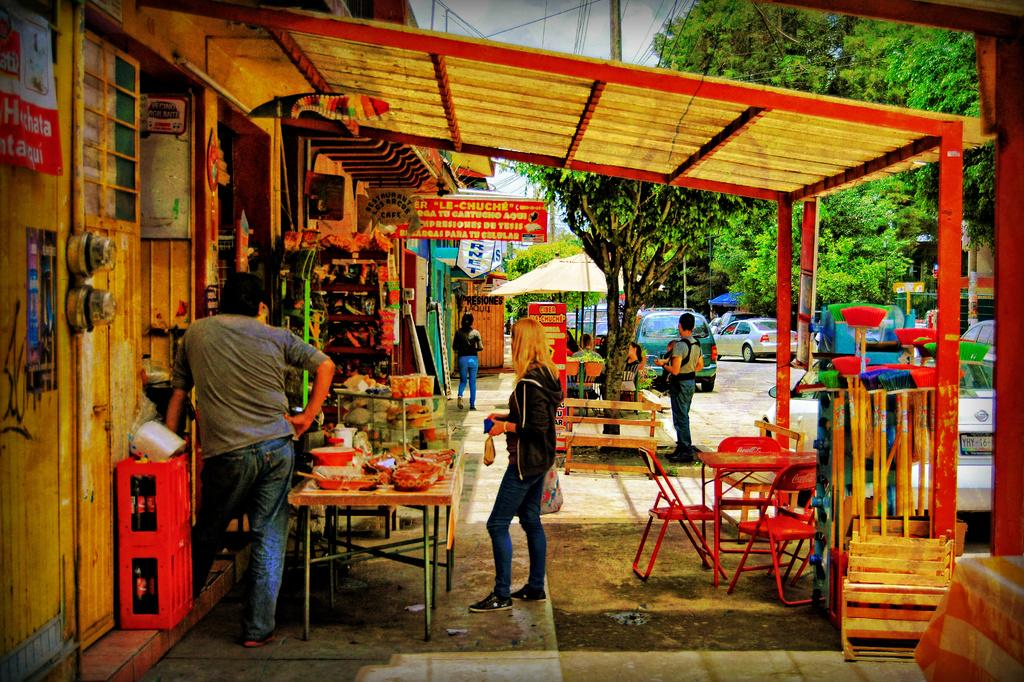Who or what can be seen in the image? There are people in the image. What type of furniture is present in the image? There are chairs and tables in the image. What kind of structures are visible in the image? There are stalls in the image. What can be seen in the background of the image? There are cars and trees in the background of the image. What type of root is growing out of the jar in the image? There is no jar or root present in the image. 